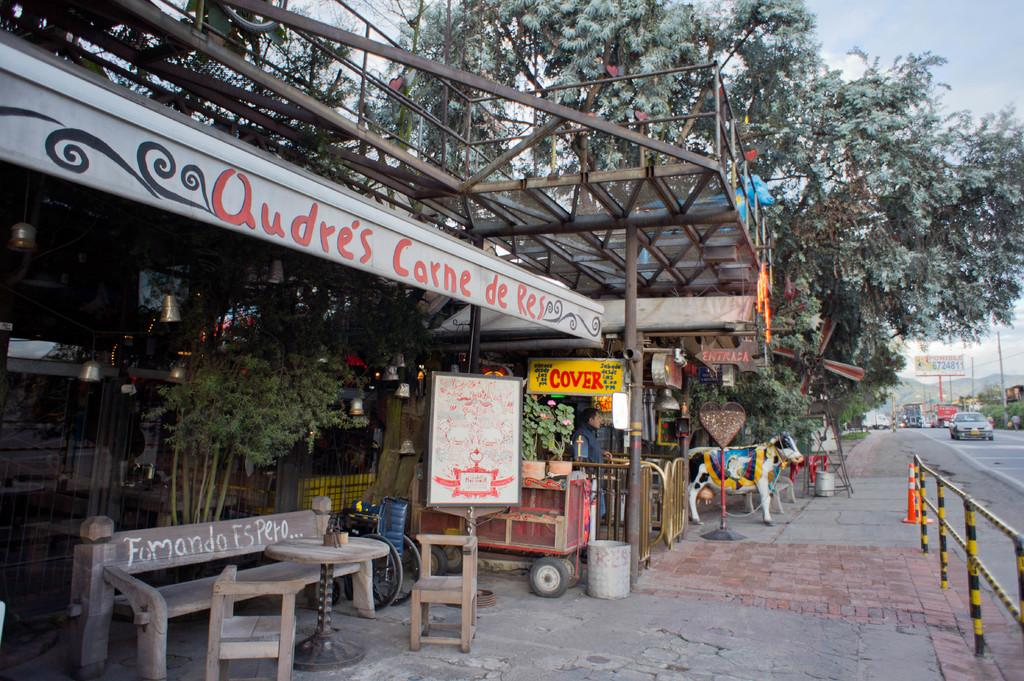What can be seen on the road in the image? There are vehicles on the road in the image. What is the person near the road doing? There is a person standing near the road. What type of natural elements are visible in the image? There are trees visible in the image. What type of establishment is present in the image? There is a shop in the image. What furniture is available for customers in the shop? The shop has benches and chairs. What is attached to the shop? There are boards on the shop. What type of barrier is associated with the shop? There is fencing associated with the shop. Can you tell me how many rocks are present in the image? There is no mention of rocks in the image; it features vehicles on the road, a person standing near the road, trees, a shop, and fencing. What is the birth rate of the people in the image? There is no information about the birth rate of the people in the image, as it only shows a person standing near the road, vehicles on the road, a shop, and trees. 